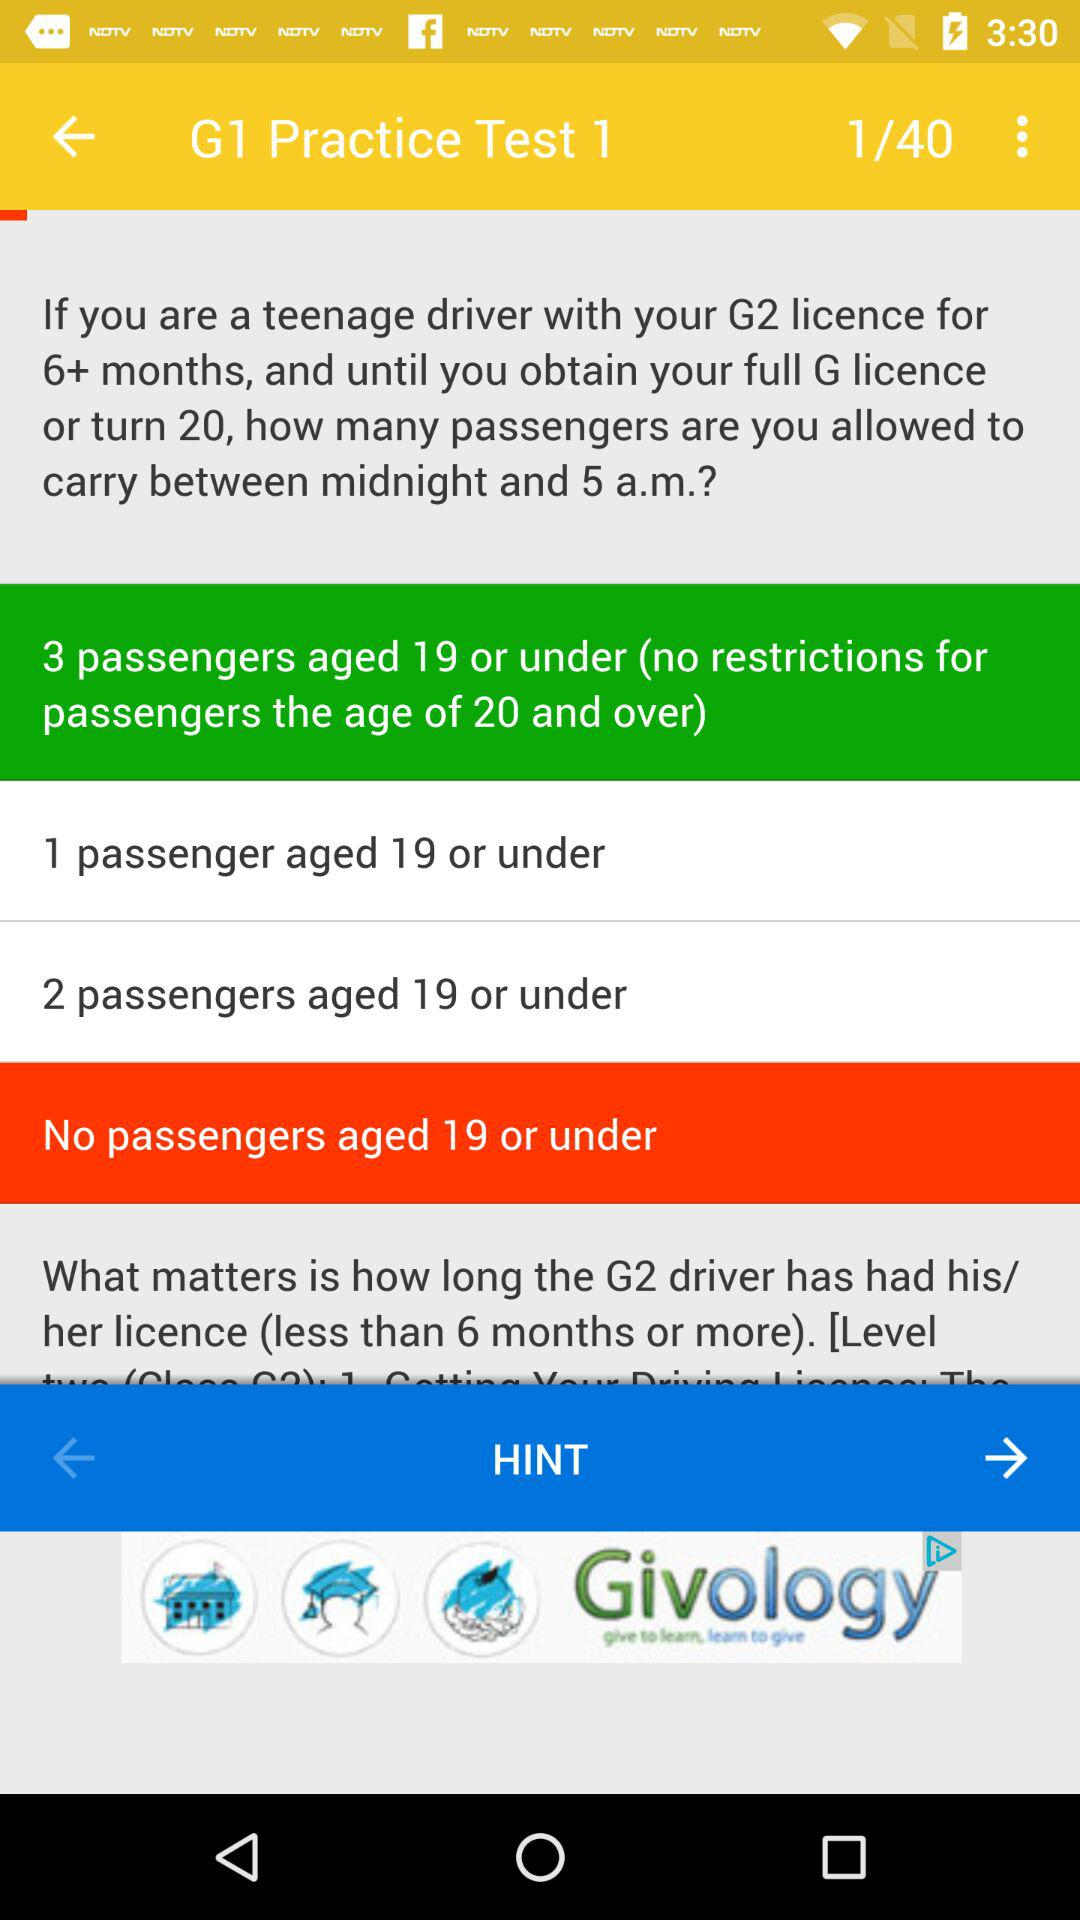How many total number of the practice test are there? The total number of the practice test are 40. 